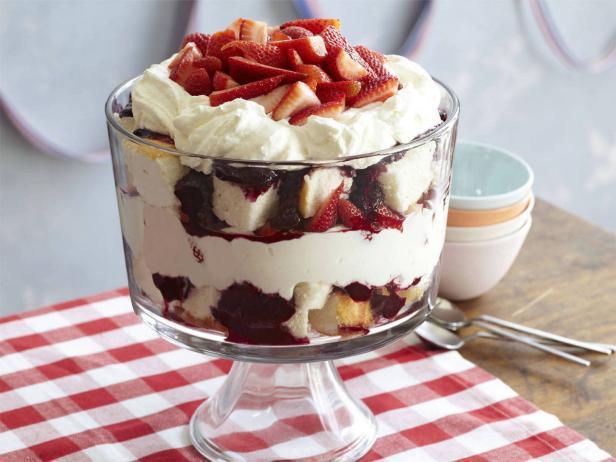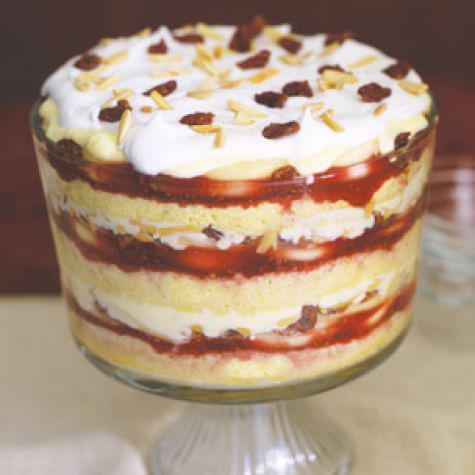The first image is the image on the left, the second image is the image on the right. Assess this claim about the two images: "A single dessert in the image on the left has a glass pedestal.". Correct or not? Answer yes or no. Yes. The first image is the image on the left, the second image is the image on the right. Assess this claim about the two images: "One image shows a dessert topped with sliced, non-heaped strawberries, and the other shows a dessert topped with a different kind of small bright red fruit.". Correct or not? Answer yes or no. No. 